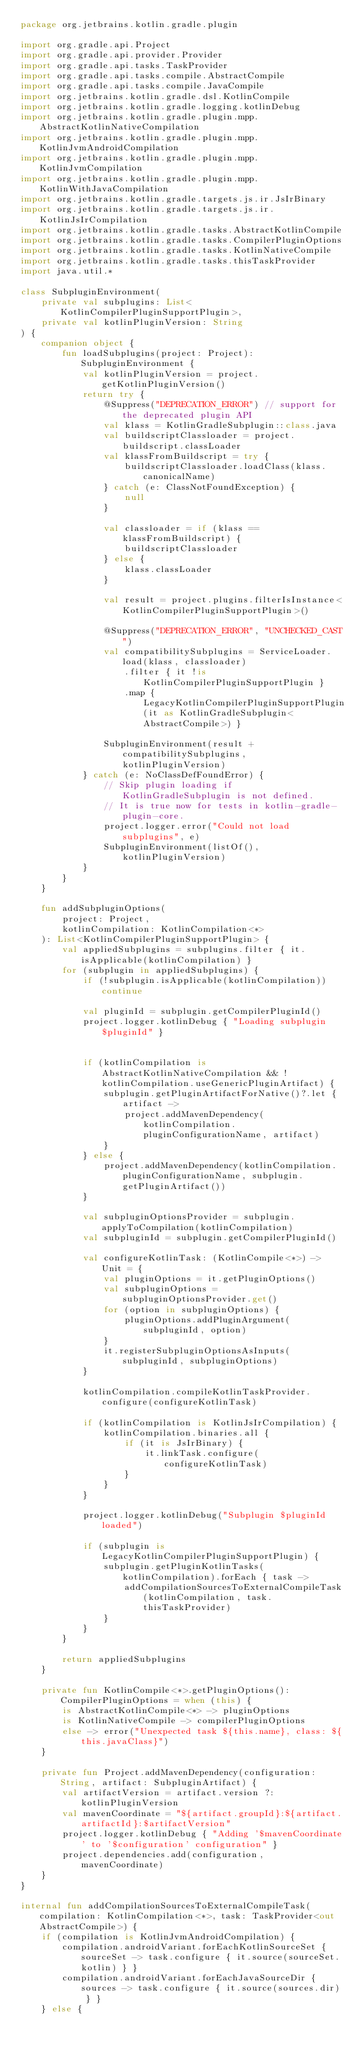<code> <loc_0><loc_0><loc_500><loc_500><_Kotlin_>package org.jetbrains.kotlin.gradle.plugin

import org.gradle.api.Project
import org.gradle.api.provider.Provider
import org.gradle.api.tasks.TaskProvider
import org.gradle.api.tasks.compile.AbstractCompile
import org.gradle.api.tasks.compile.JavaCompile
import org.jetbrains.kotlin.gradle.dsl.KotlinCompile
import org.jetbrains.kotlin.gradle.logging.kotlinDebug
import org.jetbrains.kotlin.gradle.plugin.mpp.AbstractKotlinNativeCompilation
import org.jetbrains.kotlin.gradle.plugin.mpp.KotlinJvmAndroidCompilation
import org.jetbrains.kotlin.gradle.plugin.mpp.KotlinJvmCompilation
import org.jetbrains.kotlin.gradle.plugin.mpp.KotlinWithJavaCompilation
import org.jetbrains.kotlin.gradle.targets.js.ir.JsIrBinary
import org.jetbrains.kotlin.gradle.targets.js.ir.KotlinJsIrCompilation
import org.jetbrains.kotlin.gradle.tasks.AbstractKotlinCompile
import org.jetbrains.kotlin.gradle.tasks.CompilerPluginOptions
import org.jetbrains.kotlin.gradle.tasks.KotlinNativeCompile
import org.jetbrains.kotlin.gradle.tasks.thisTaskProvider
import java.util.*

class SubpluginEnvironment(
    private val subplugins: List<KotlinCompilerPluginSupportPlugin>,
    private val kotlinPluginVersion: String
) {
    companion object {
        fun loadSubplugins(project: Project): SubpluginEnvironment {
            val kotlinPluginVersion = project.getKotlinPluginVersion()
            return try {
                @Suppress("DEPRECATION_ERROR") // support for the deprecated plugin API
                val klass = KotlinGradleSubplugin::class.java
                val buildscriptClassloader = project.buildscript.classLoader
                val klassFromBuildscript = try {
                    buildscriptClassloader.loadClass(klass.canonicalName)
                } catch (e: ClassNotFoundException) {
                    null
                }

                val classloader = if (klass == klassFromBuildscript) {
                    buildscriptClassloader
                } else {
                    klass.classLoader
                }

                val result = project.plugins.filterIsInstance<KotlinCompilerPluginSupportPlugin>()

                @Suppress("DEPRECATION_ERROR", "UNCHECKED_CAST")
                val compatibilitySubplugins = ServiceLoader.load(klass, classloader)
                    .filter { it !is KotlinCompilerPluginSupportPlugin }
                    .map { LegacyKotlinCompilerPluginSupportPlugin(it as KotlinGradleSubplugin<AbstractCompile>) }

                SubpluginEnvironment(result + compatibilitySubplugins, kotlinPluginVersion)
            } catch (e: NoClassDefFoundError) {
                // Skip plugin loading if KotlinGradleSubplugin is not defined.
                // It is true now for tests in kotlin-gradle-plugin-core.
                project.logger.error("Could not load subplugins", e)
                SubpluginEnvironment(listOf(), kotlinPluginVersion)
            }
        }
    }

    fun addSubpluginOptions(
        project: Project,
        kotlinCompilation: KotlinCompilation<*>
    ): List<KotlinCompilerPluginSupportPlugin> {
        val appliedSubplugins = subplugins.filter { it.isApplicable(kotlinCompilation) }
        for (subplugin in appliedSubplugins) {
            if (!subplugin.isApplicable(kotlinCompilation)) continue

            val pluginId = subplugin.getCompilerPluginId()
            project.logger.kotlinDebug { "Loading subplugin $pluginId" }


            if (kotlinCompilation is AbstractKotlinNativeCompilation && !kotlinCompilation.useGenericPluginArtifact) {
                subplugin.getPluginArtifactForNative()?.let { artifact ->
                    project.addMavenDependency(kotlinCompilation.pluginConfigurationName, artifact)
                }
            } else {
                project.addMavenDependency(kotlinCompilation.pluginConfigurationName, subplugin.getPluginArtifact())
            }

            val subpluginOptionsProvider = subplugin.applyToCompilation(kotlinCompilation)
            val subpluginId = subplugin.getCompilerPluginId()

            val configureKotlinTask: (KotlinCompile<*>) -> Unit = {
                val pluginOptions = it.getPluginOptions()
                val subpluginOptions = subpluginOptionsProvider.get()
                for (option in subpluginOptions) {
                    pluginOptions.addPluginArgument(subpluginId, option)
                }
                it.registerSubpluginOptionsAsInputs(subpluginId, subpluginOptions)
            }

            kotlinCompilation.compileKotlinTaskProvider.configure(configureKotlinTask)

            if (kotlinCompilation is KotlinJsIrCompilation) {
                kotlinCompilation.binaries.all {
                    if (it is JsIrBinary) {
                        it.linkTask.configure(configureKotlinTask)
                    }
                }
            }

            project.logger.kotlinDebug("Subplugin $pluginId loaded")

            if (subplugin is LegacyKotlinCompilerPluginSupportPlugin) {
                subplugin.getPluginKotlinTasks(kotlinCompilation).forEach { task ->
                    addCompilationSourcesToExternalCompileTask(kotlinCompilation, task.thisTaskProvider)
                }
            }
        }

        return appliedSubplugins
    }

    private fun KotlinCompile<*>.getPluginOptions(): CompilerPluginOptions = when (this) {
        is AbstractKotlinCompile<*> -> pluginOptions
        is KotlinNativeCompile -> compilerPluginOptions
        else -> error("Unexpected task ${this.name}, class: ${this.javaClass}")
    }

    private fun Project.addMavenDependency(configuration: String, artifact: SubpluginArtifact) {
        val artifactVersion = artifact.version ?: kotlinPluginVersion
        val mavenCoordinate = "${artifact.groupId}:${artifact.artifactId}:$artifactVersion"
        project.logger.kotlinDebug { "Adding '$mavenCoordinate' to '$configuration' configuration" }
        project.dependencies.add(configuration, mavenCoordinate)
    }
}

internal fun addCompilationSourcesToExternalCompileTask(compilation: KotlinCompilation<*>, task: TaskProvider<out AbstractCompile>) {
    if (compilation is KotlinJvmAndroidCompilation) {
        compilation.androidVariant.forEachKotlinSourceSet { sourceSet -> task.configure { it.source(sourceSet.kotlin) } }
        compilation.androidVariant.forEachJavaSourceDir { sources -> task.configure { it.source(sources.dir) } }
    } else {</code> 